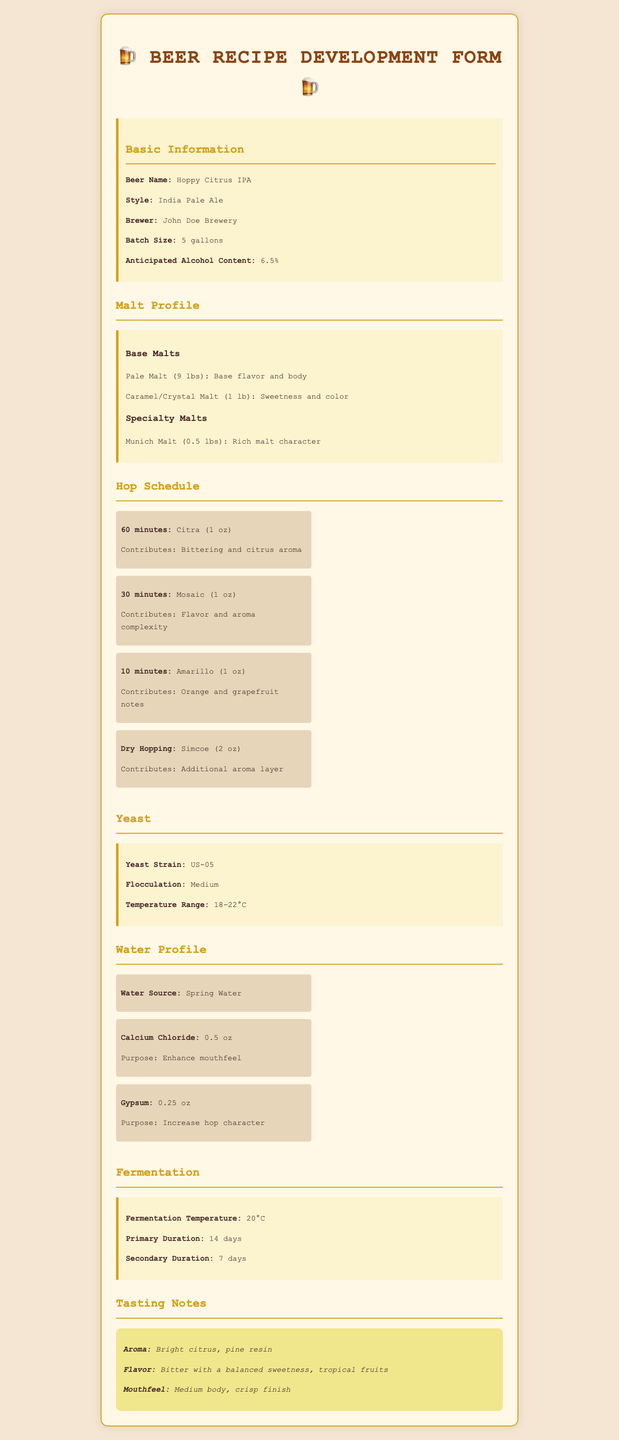What is the name of the beer? The document specifies the beer's name in the basic information section.
Answer: Hoppy Citrus IPA What is the anticipated alcohol content? The alcohol content can be found in the basic information section of the document.
Answer: 6.5% How many ounces of Citra hops are used? The hop schedule outlines the amounts of each hop used, including Citra.
Answer: 1 oz What is the primary yeast strain used? The yeast section identifies the yeast strain selected for the recipe.
Answer: US-05 What is the fermentation temperature? The fermentation section provides details on the temperature during fermentation.
Answer: 20°C How long is the primary fermentation duration? The primary fermentation duration is mentioned in the fermentation section of the document.
Answer: 14 days What is used to enhance mouthfeel in the water profile? The water profile indicates specific additions that affect mouthfeel.
Answer: Calcium Chloride What flavor profile is expected from Amarillo hops? The hop schedule details the flavor contributions of Amarillo hops.
Answer: Orange and grapefruit notes Which malt contributes sweetness and color? The malt profile includes descriptions of each malt's contribution, including sweetness and color.
Answer: Caramel/Crystal Malt 